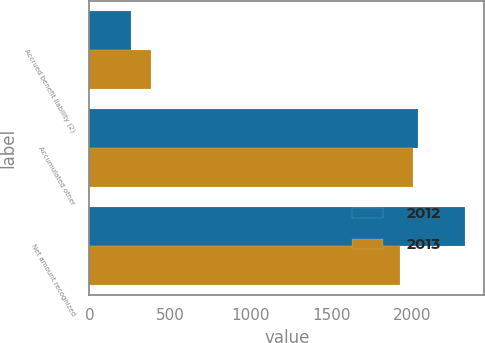<chart> <loc_0><loc_0><loc_500><loc_500><stacked_bar_chart><ecel><fcel>Accrued benefit liability (2)<fcel>Accumulated other<fcel>Net amount recognized<nl><fcel>2012<fcel>257<fcel>2036<fcel>2328<nl><fcel>2013<fcel>385<fcel>2005<fcel>1921<nl></chart> 